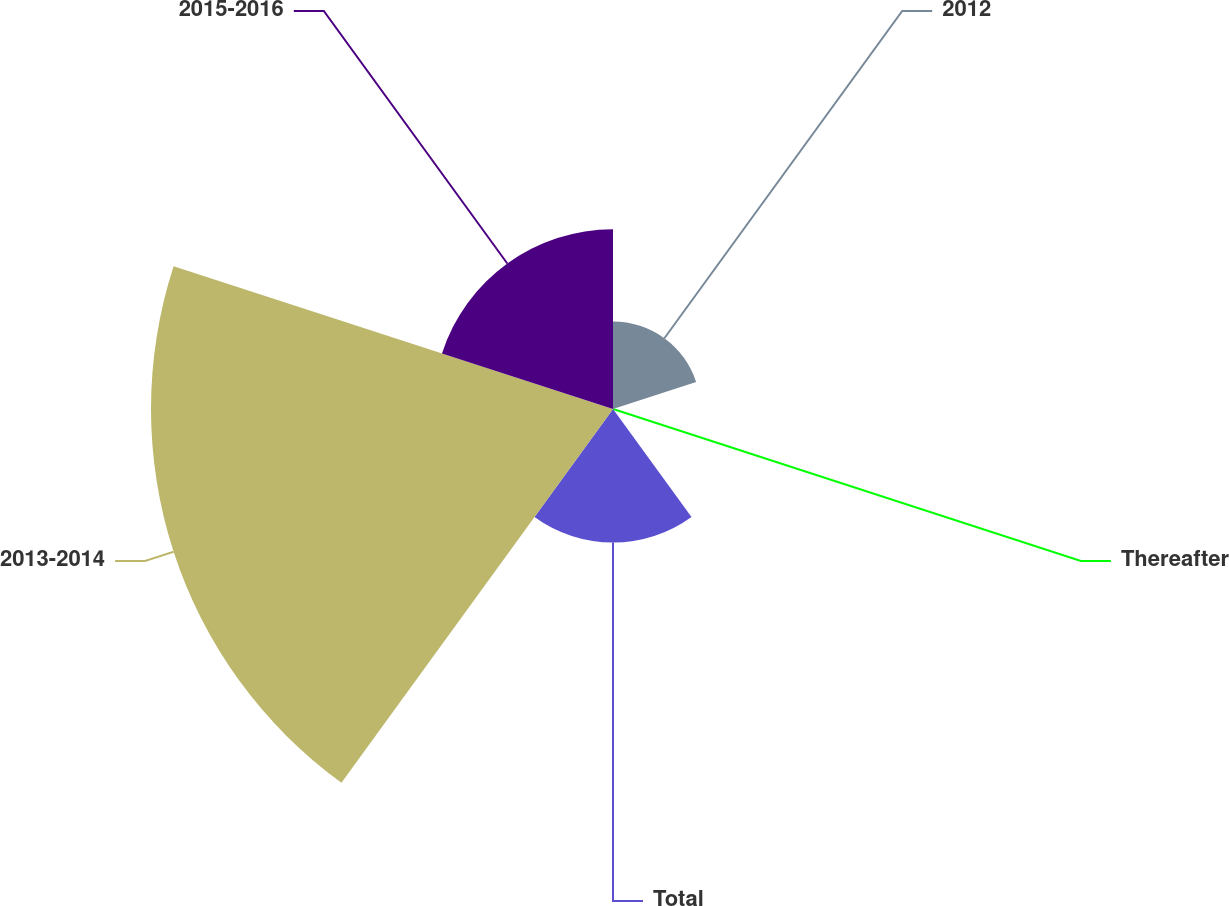Convert chart. <chart><loc_0><loc_0><loc_500><loc_500><pie_chart><fcel>2012<fcel>Thereafter<fcel>Total<fcel>2013-2014<fcel>2015-2016<nl><fcel>10.13%<fcel>0.01%<fcel>15.48%<fcel>53.54%<fcel>20.84%<nl></chart> 